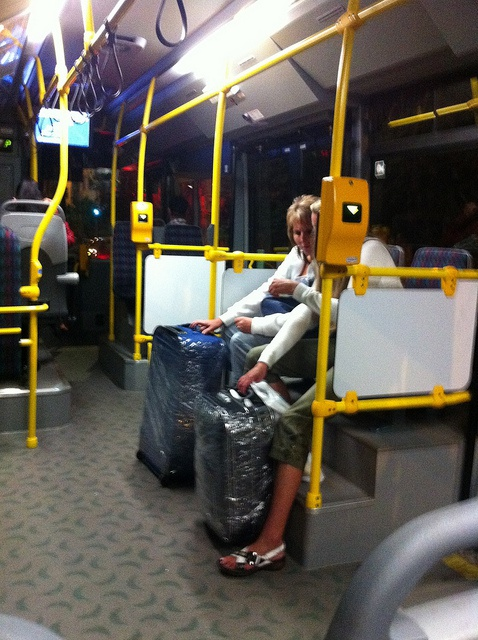Describe the objects in this image and their specific colors. I can see people in tan, black, maroon, white, and gray tones, suitcase in tan, black, gray, purple, and darkgray tones, suitcase in tan, black, darkblue, and gray tones, people in tan, white, gray, black, and darkgray tones, and people in tan, black, gray, and brown tones in this image. 